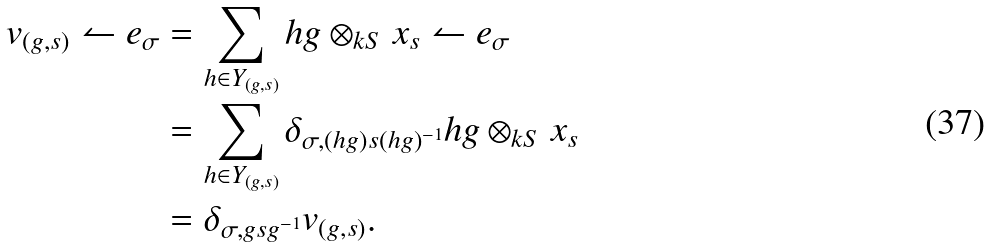<formula> <loc_0><loc_0><loc_500><loc_500>v _ { ( g , s ) } \leftharpoonup e _ { \sigma } & = \sum _ { h \in Y _ { ( g , s ) } } h g \otimes _ { k S } x _ { s } \leftharpoonup e _ { \sigma } \\ & = \sum _ { h \in Y _ { ( g , s ) } } \delta _ { \sigma , ( h g ) s ( h g ) ^ { - 1 } } h g \otimes _ { k S } x _ { s } \\ & = \delta _ { \sigma , g s g ^ { - 1 } } v _ { ( g , s ) } .</formula> 